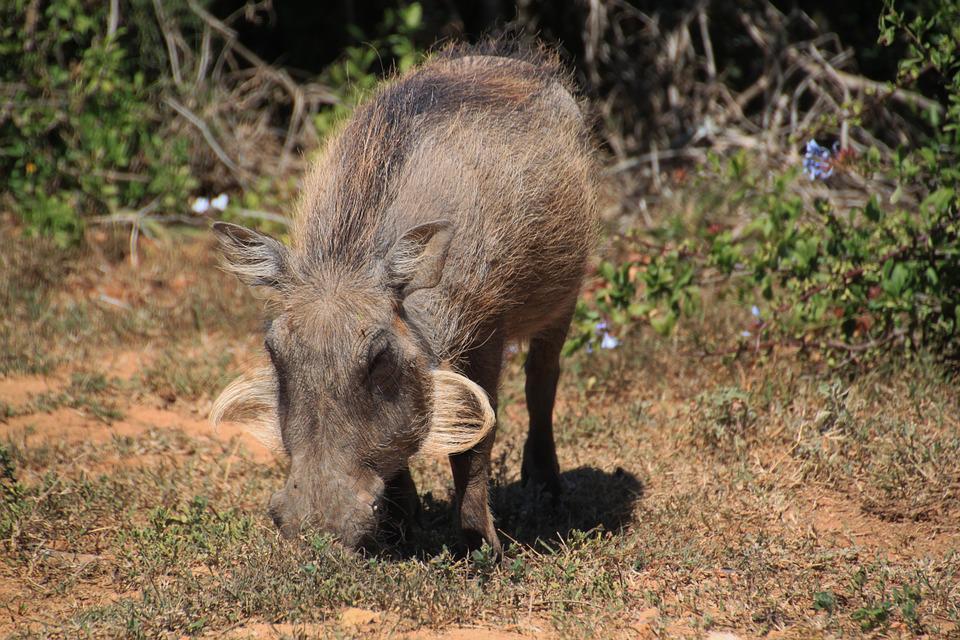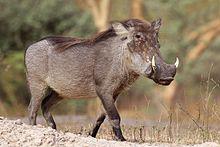The first image is the image on the left, the second image is the image on the right. Evaluate the accuracy of this statement regarding the images: "Three animals, including an adult warthog, are in the left image.". Is it true? Answer yes or no. No. 